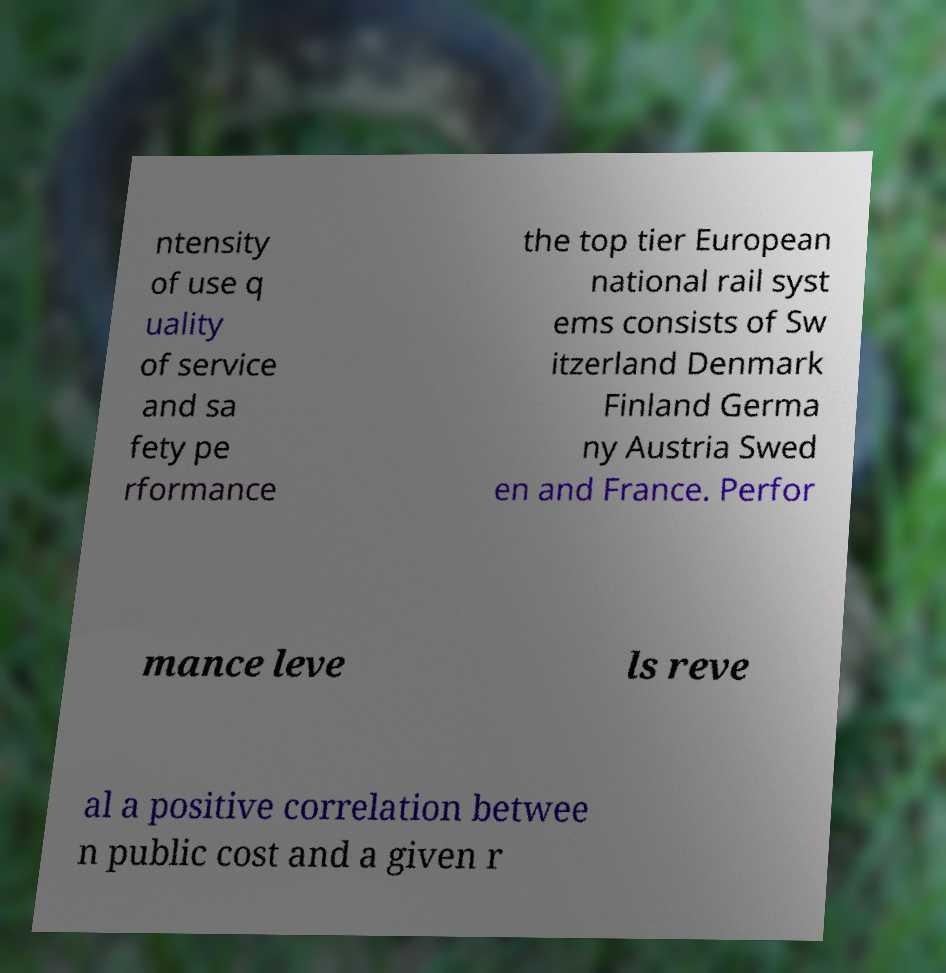Could you assist in decoding the text presented in this image and type it out clearly? ntensity of use q uality of service and sa fety pe rformance the top tier European national rail syst ems consists of Sw itzerland Denmark Finland Germa ny Austria Swed en and France. Perfor mance leve ls reve al a positive correlation betwee n public cost and a given r 